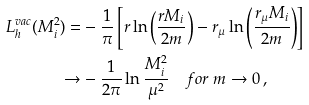Convert formula to latex. <formula><loc_0><loc_0><loc_500><loc_500>L _ { h } ^ { v a c } ( M _ { i } ^ { 2 } ) = & - \frac { 1 } { \pi } \left [ r \ln \left ( \frac { r M _ { i } } { 2 m } \right ) - r _ { \mu } \ln \left ( \frac { r _ { \mu } M _ { i } } { 2 m } \right ) \right ] \\ \rightarrow & - \frac { 1 } { 2 \pi } \ln \frac { M _ { i } ^ { 2 } } { \mu ^ { 2 } } \quad f o r \ m \rightarrow 0 \, ,</formula> 